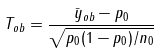Convert formula to latex. <formula><loc_0><loc_0><loc_500><loc_500>T _ { o b } = \frac { \bar { y } _ { o b } - p _ { 0 } } { \sqrt { p _ { 0 } ( 1 - p _ { 0 } ) / n _ { 0 } } }</formula> 